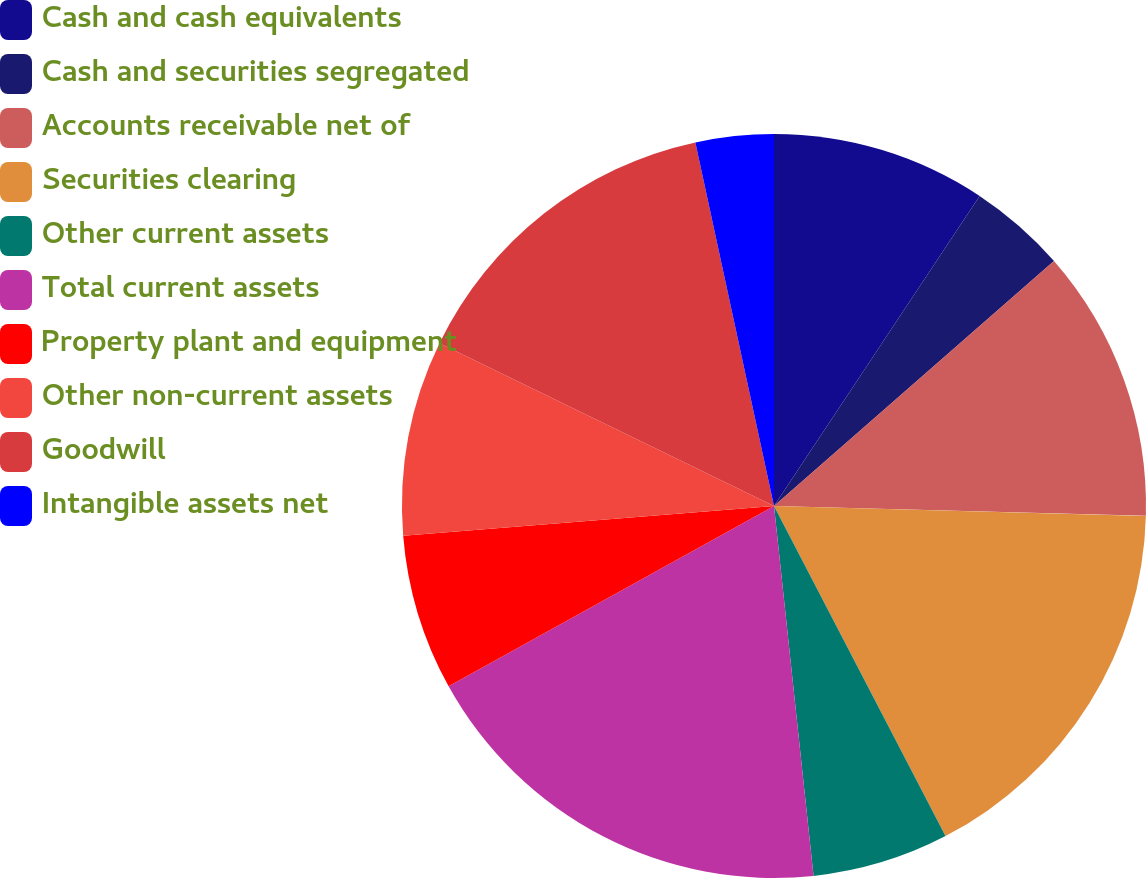Convert chart to OTSL. <chart><loc_0><loc_0><loc_500><loc_500><pie_chart><fcel>Cash and cash equivalents<fcel>Cash and securities segregated<fcel>Accounts receivable net of<fcel>Securities clearing<fcel>Other current assets<fcel>Total current assets<fcel>Property plant and equipment<fcel>Other non-current assets<fcel>Goodwill<fcel>Intangible assets net<nl><fcel>9.32%<fcel>4.24%<fcel>11.86%<fcel>16.95%<fcel>5.93%<fcel>18.64%<fcel>6.78%<fcel>8.48%<fcel>14.4%<fcel>3.39%<nl></chart> 